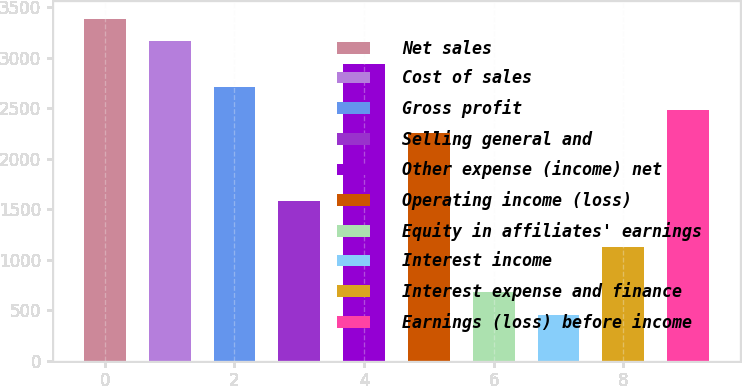<chart> <loc_0><loc_0><loc_500><loc_500><bar_chart><fcel>Net sales<fcel>Cost of sales<fcel>Gross profit<fcel>Selling general and<fcel>Other expense (income) net<fcel>Operating income (loss)<fcel>Equity in affiliates' earnings<fcel>Interest income<fcel>Interest expense and finance<fcel>Earnings (loss) before income<nl><fcel>3387.79<fcel>3162.03<fcel>2710.51<fcel>1581.71<fcel>2936.27<fcel>2258.99<fcel>678.67<fcel>452.91<fcel>1130.19<fcel>2484.75<nl></chart> 